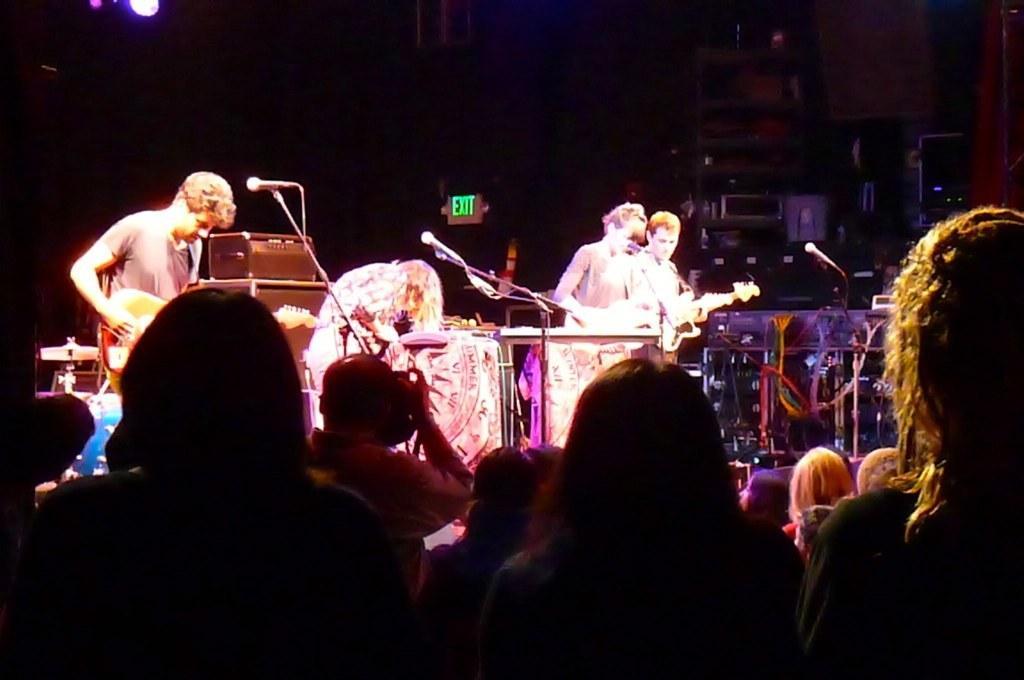Could you give a brief overview of what you see in this image? In this picture there are group of people those who are standing on the stage at the center of the image and there are group of audience those who are standing in front of the stage and there are spotlights above the area of the image. 